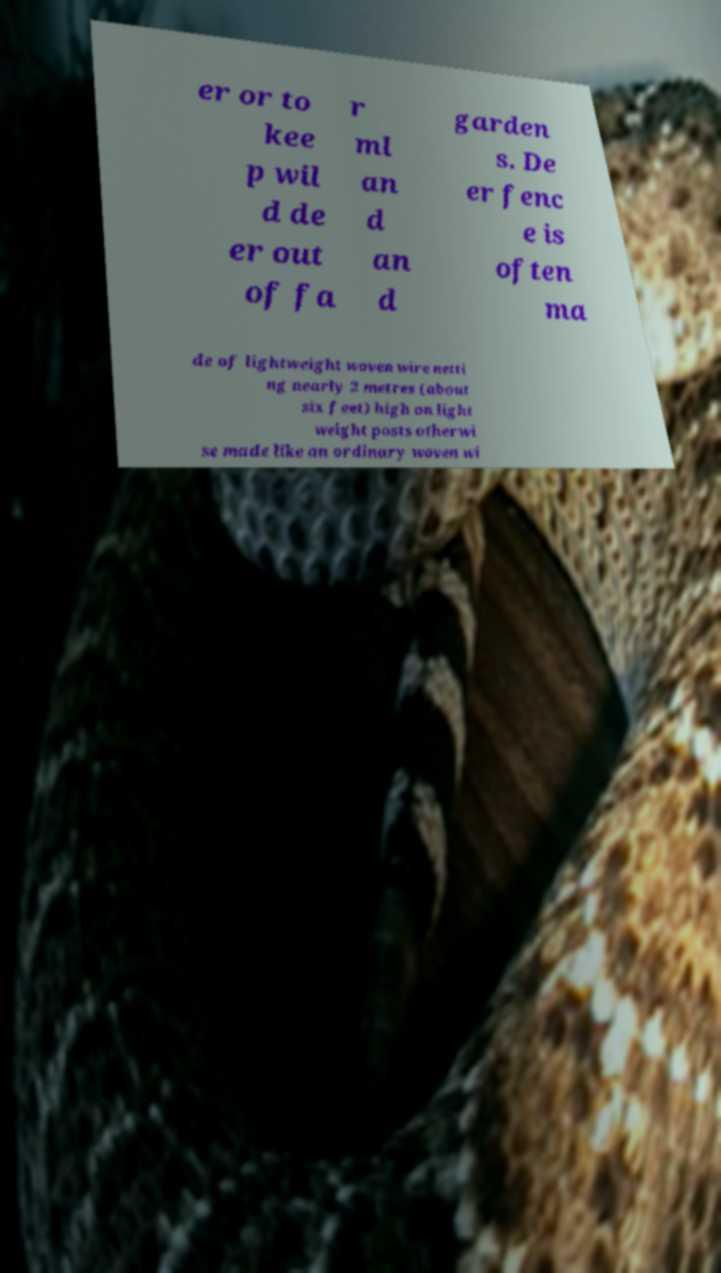There's text embedded in this image that I need extracted. Can you transcribe it verbatim? er or to kee p wil d de er out of fa r ml an d an d garden s. De er fenc e is often ma de of lightweight woven wire netti ng nearly 2 metres (about six feet) high on light weight posts otherwi se made like an ordinary woven wi 